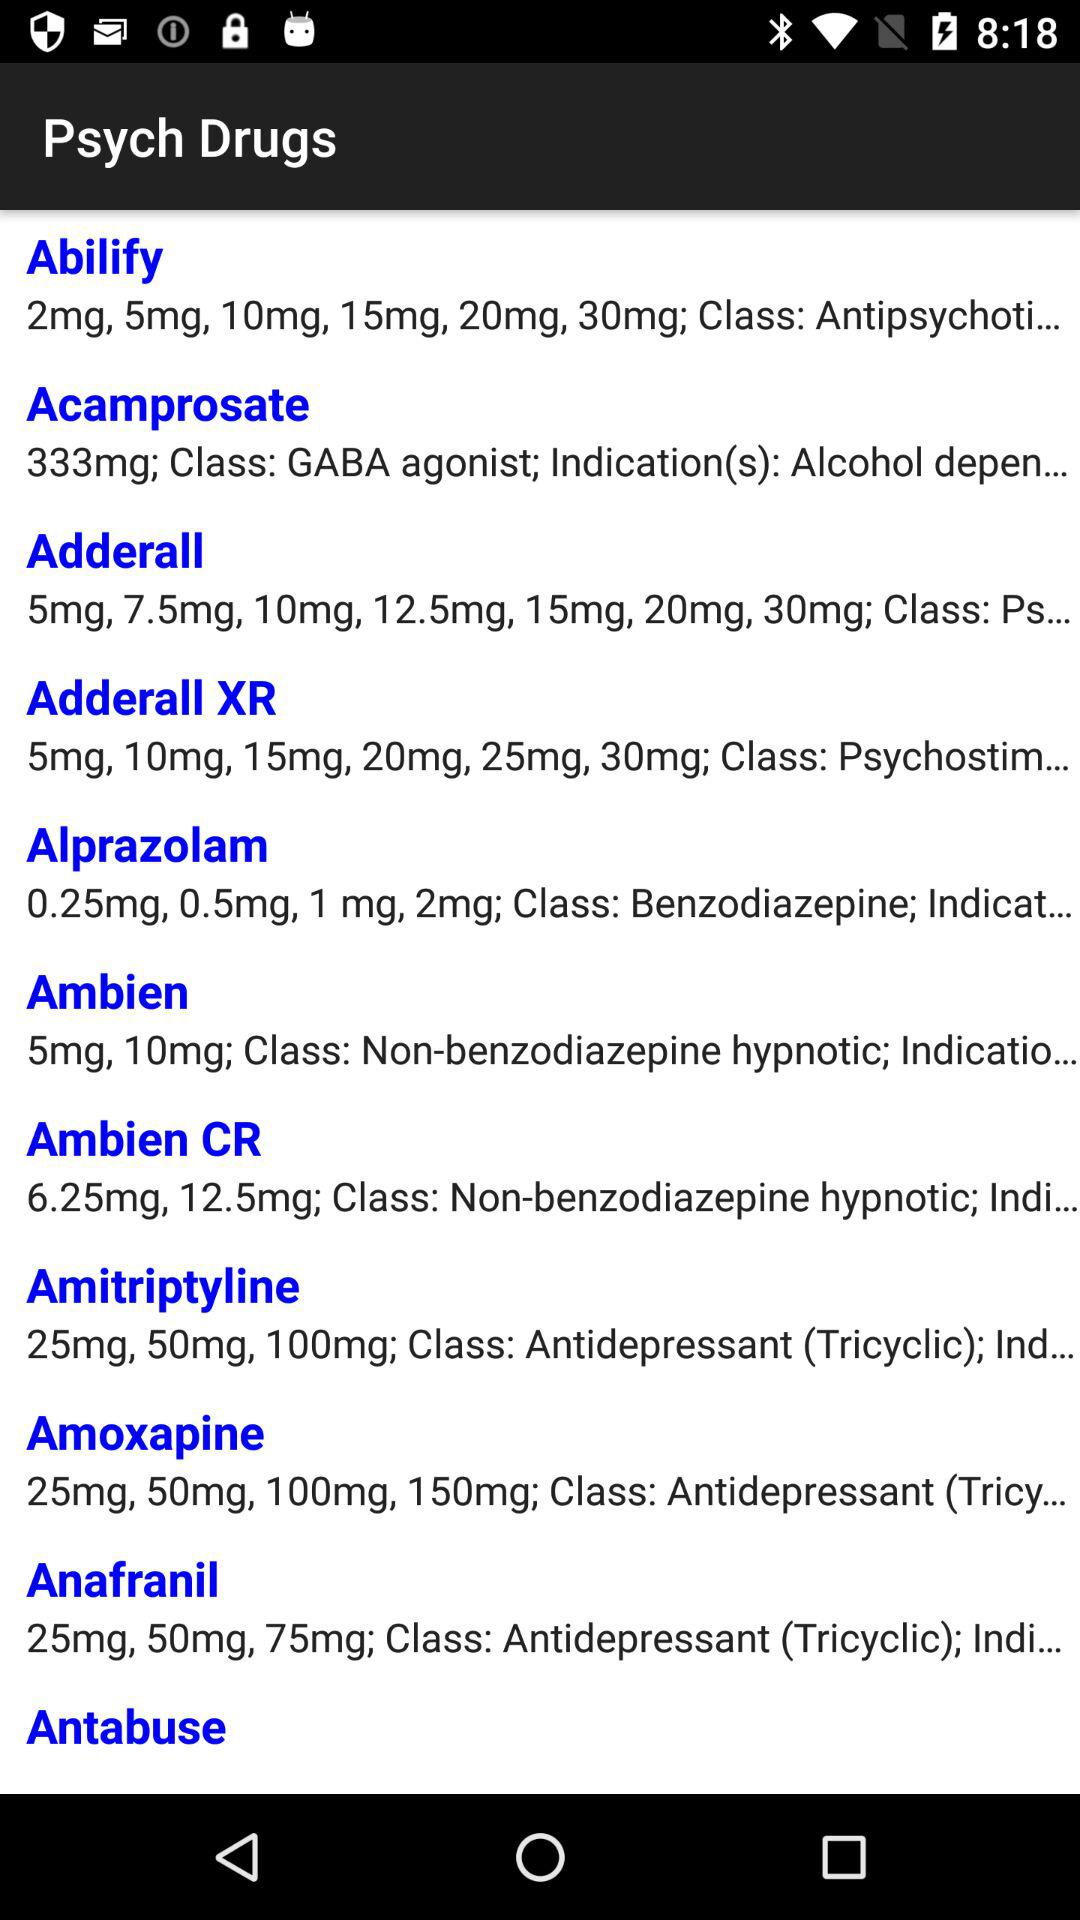Which class of drugs does Anafranil belong to? Anafranil belongs to "Antidepressant (Tricyclic)" class of drugs. 